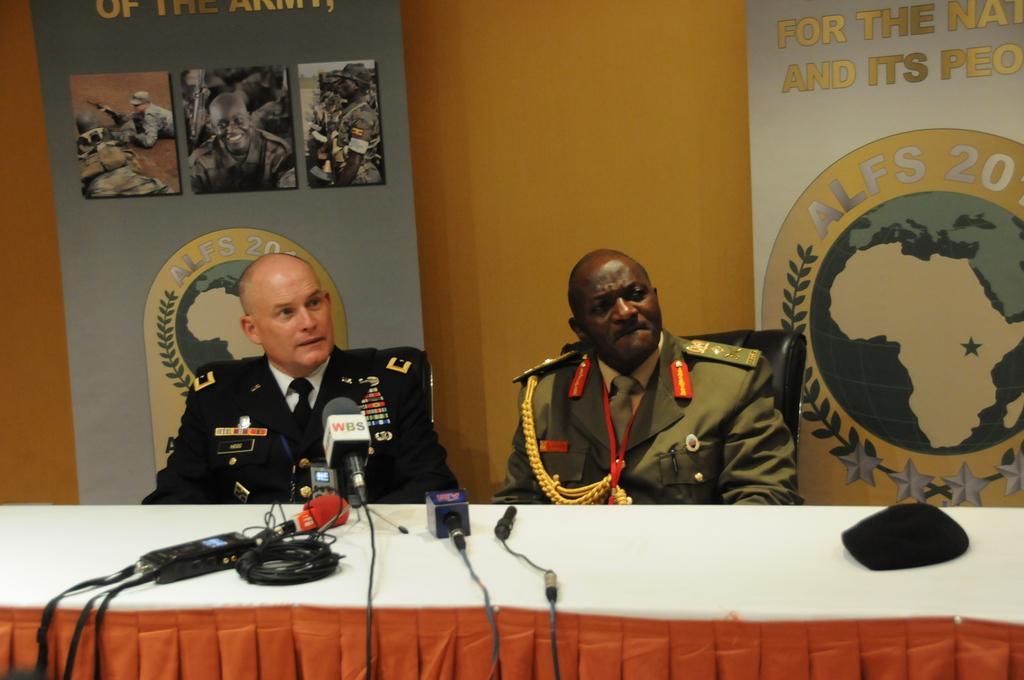In one or two sentences, can you explain what this image depicts? In the picture,there are two officers sitting in front of a table and they are being interviewed there are some mics kept in front of the officers and behind them there are big banners with some photos. 